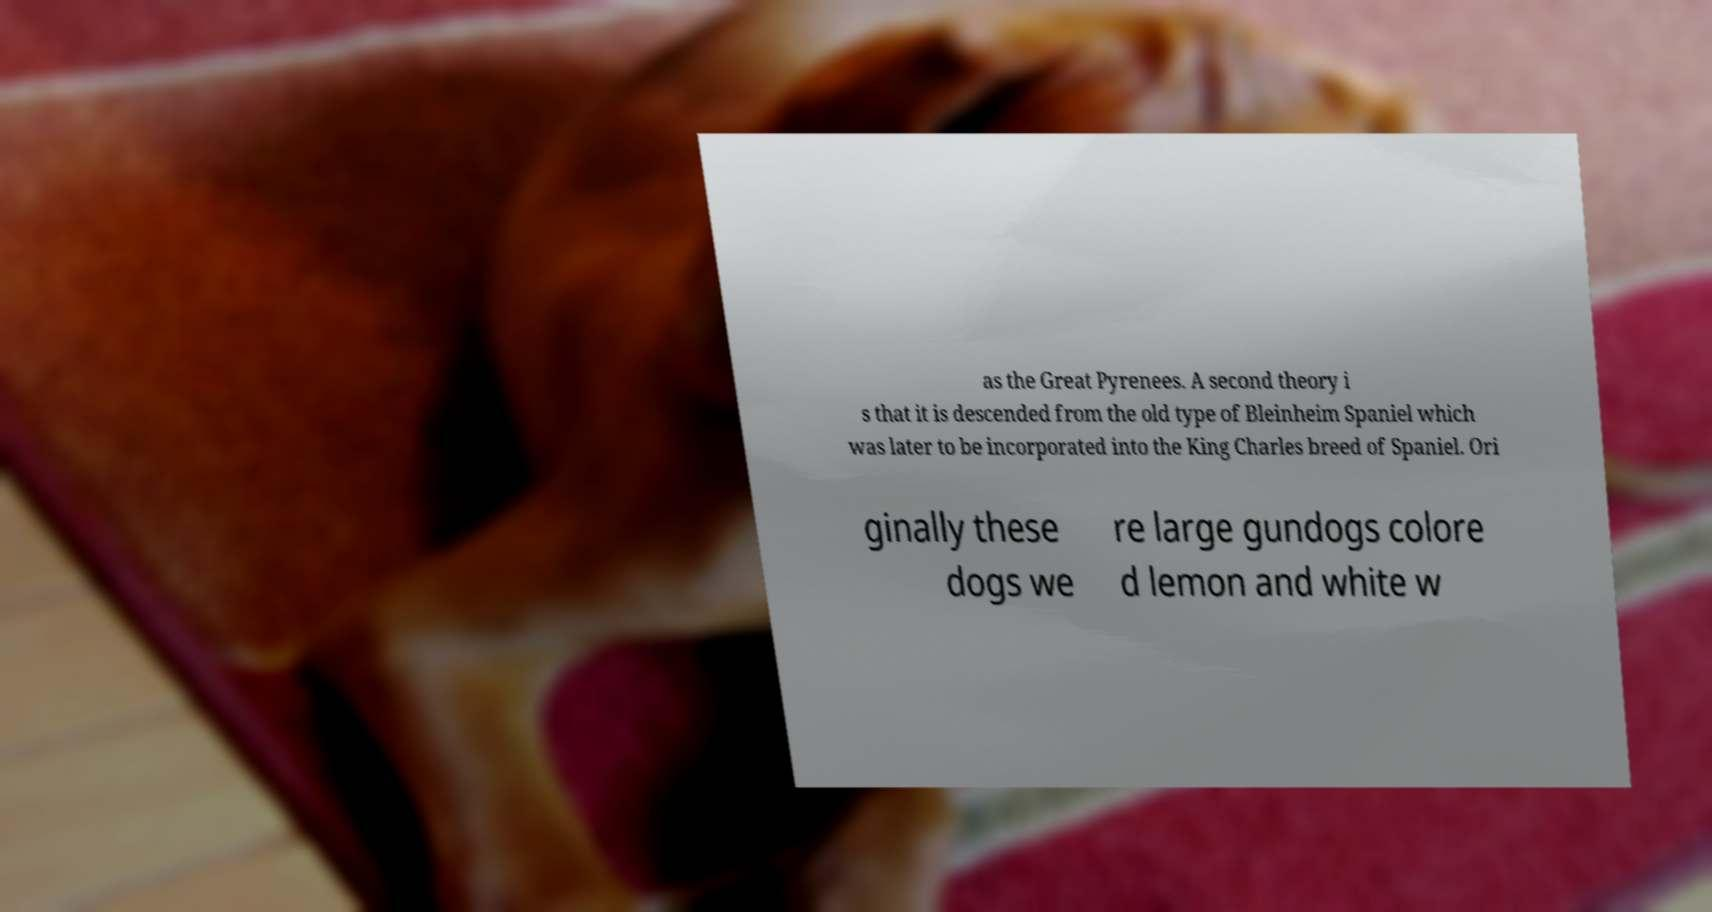Can you accurately transcribe the text from the provided image for me? as the Great Pyrenees. A second theory i s that it is descended from the old type of Bleinheim Spaniel which was later to be incorporated into the King Charles breed of Spaniel. Ori ginally these dogs we re large gundogs colore d lemon and white w 